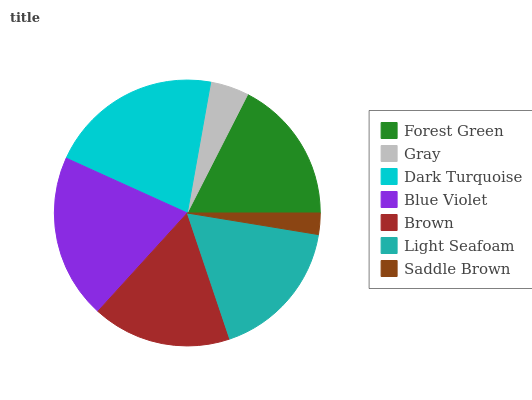Is Saddle Brown the minimum?
Answer yes or no. Yes. Is Dark Turquoise the maximum?
Answer yes or no. Yes. Is Gray the minimum?
Answer yes or no. No. Is Gray the maximum?
Answer yes or no. No. Is Forest Green greater than Gray?
Answer yes or no. Yes. Is Gray less than Forest Green?
Answer yes or no. Yes. Is Gray greater than Forest Green?
Answer yes or no. No. Is Forest Green less than Gray?
Answer yes or no. No. Is Light Seafoam the high median?
Answer yes or no. Yes. Is Light Seafoam the low median?
Answer yes or no. Yes. Is Brown the high median?
Answer yes or no. No. Is Blue Violet the low median?
Answer yes or no. No. 